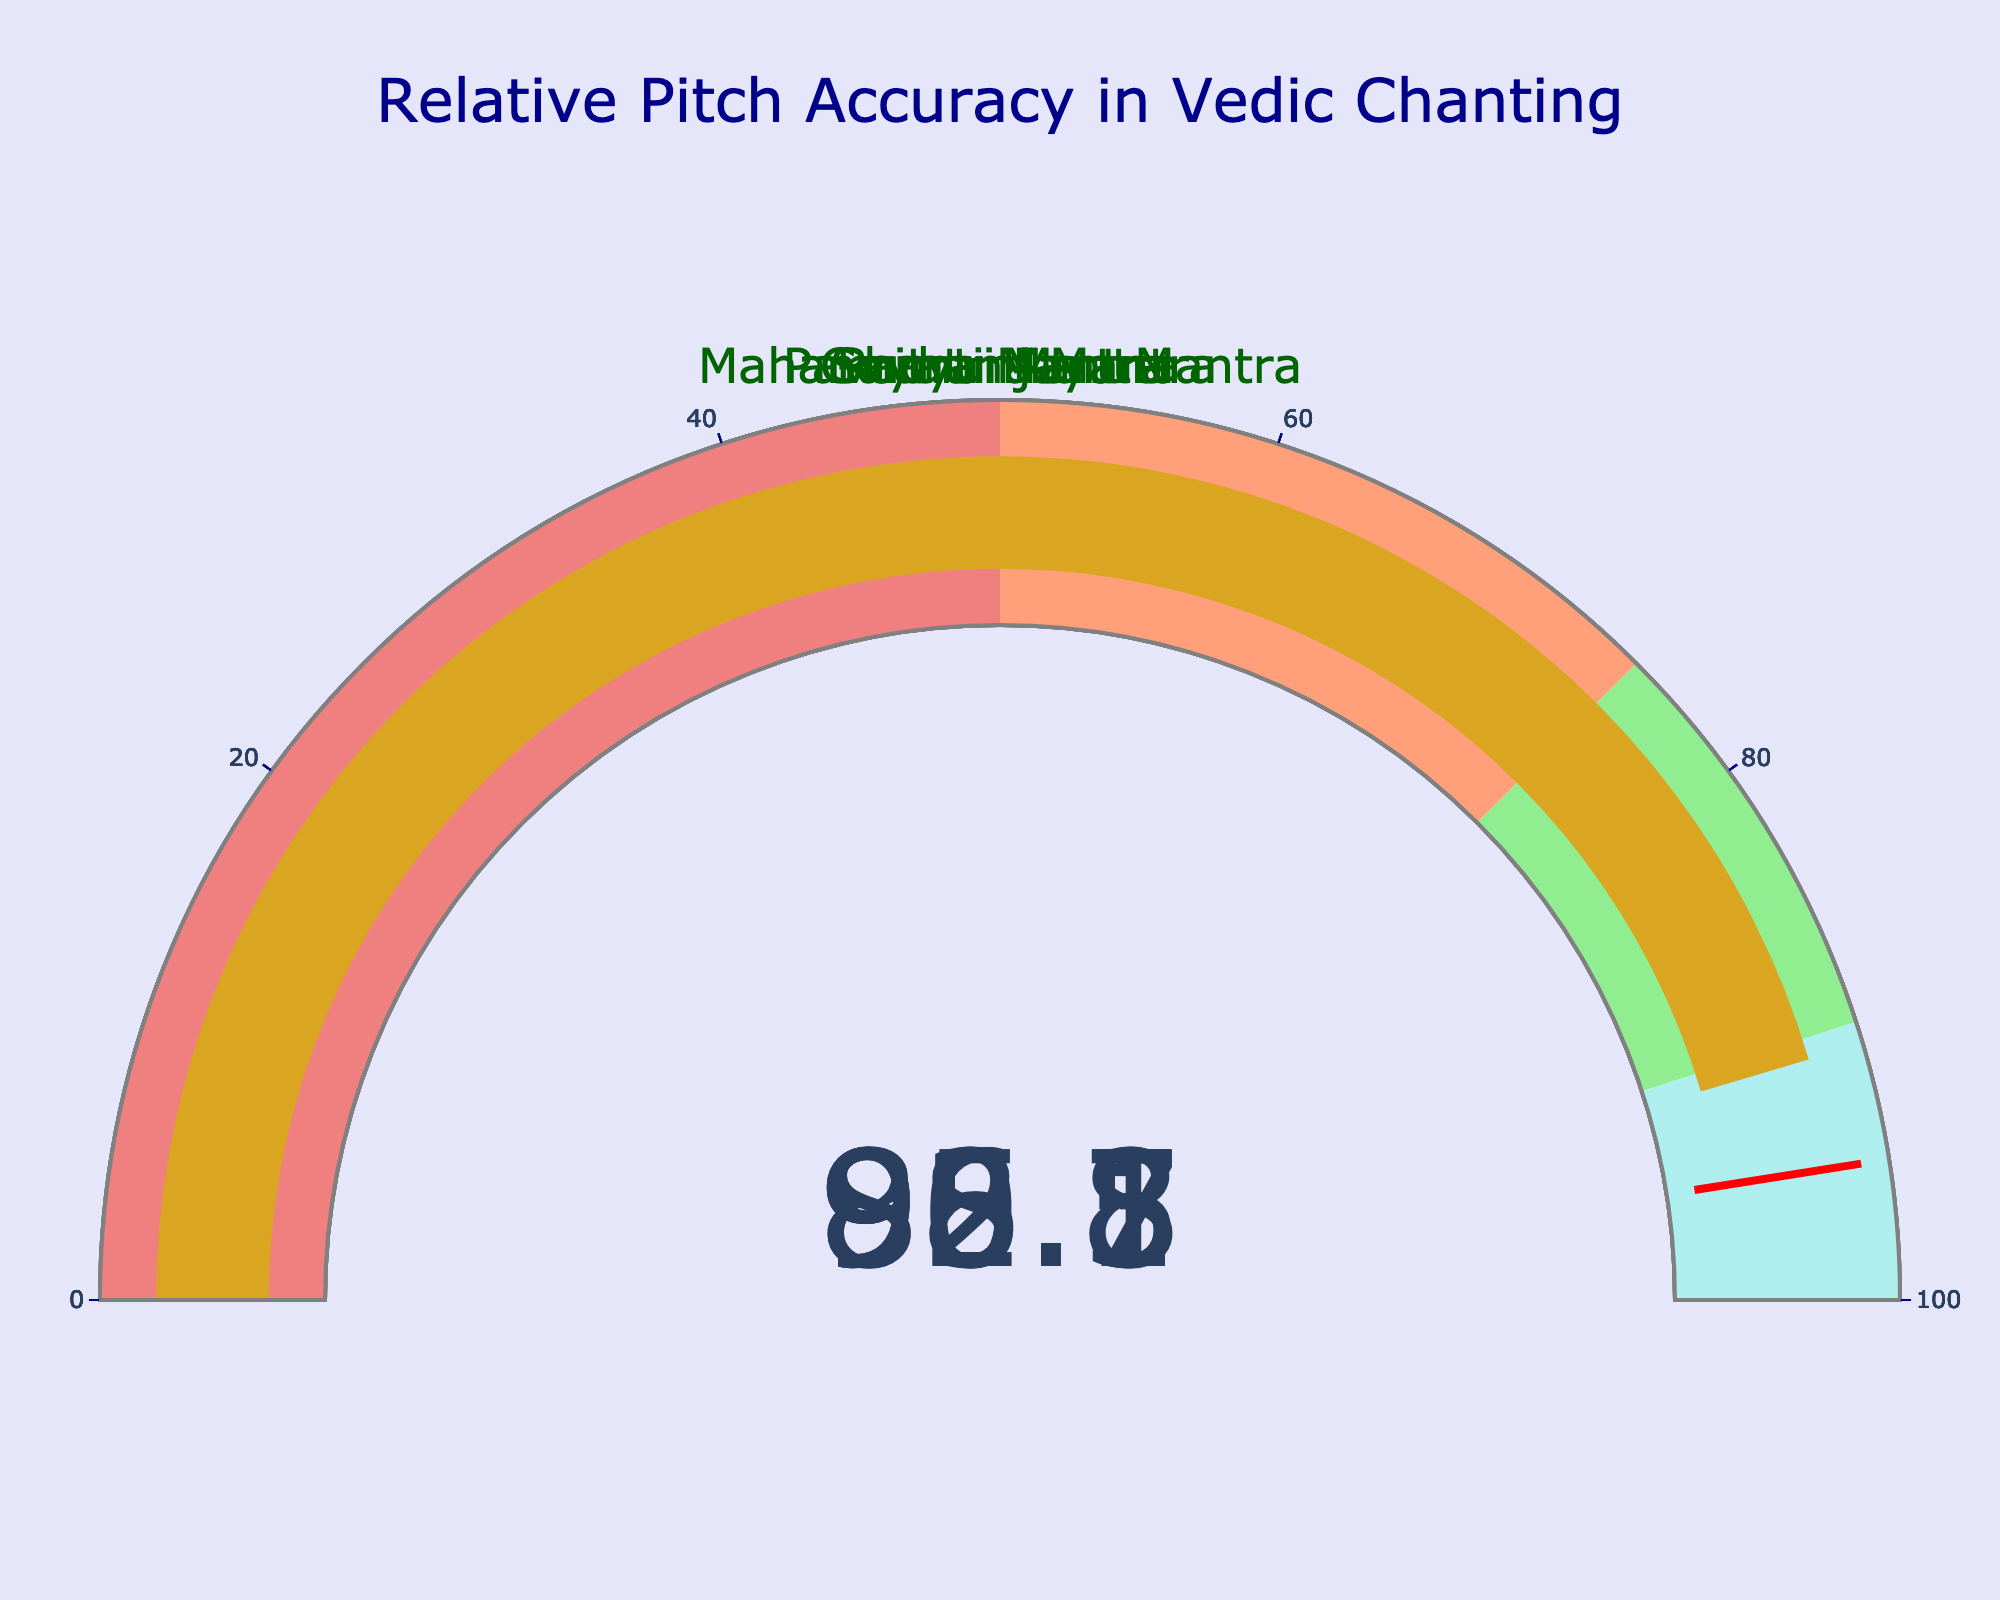What's the relative pitch accuracy of the Gayatri Mantra? The figure shows a gauge for each mantra with the pitch accuracy displayed as a number. We can directly read the Gayatri Mantra's gauge.
Answer: 92.5 How many mantras have a pitch accuracy of over 90%? By examining each gauge, we note the pitch accuracies of each mantra. Gayatri Mantra: 92.5, Mahamrityunjaya Mantra: 88.7, Shanti Mantra: 95.1, Pavamana Mantra: 86.3, Rudra Mantra: 90.8. Counting the values above 90 gives us three.
Answer: 3 What is the average relative pitch accuracy of all the mantras? We sum up all the accuracies and divide by the number of mantras: (92.5 + 88.7 + 95.1 + 86.3 + 90.8) / 5 = 453.4 / 5 = 90.68.
Answer: 90.68 Which mantra has the lowest relative pitch accuracy? By comparing the pitch accuracies directly, the lowest value is Pavamana Mantra with 86.3
Answer: Pavamana Mantra Is there any mantra with a pitch accuracy of exactly 95% or higher? Checking each gauge, the Shanti Mantra has an accuracy of 95.1, which meets the condition.
Answer: Yes What's the difference in pitch accuracy between the Shanti Mantra and the Rudra Mantra? Shanti Mantra's pitch accuracy is 95.1, and Rudra Mantra's is 90.8. The difference is 95.1 - 90.8 = 4.3.
Answer: 4.3 Which mantra has a pitch accuracy closest to 90%? We need to check the values that are closest to 90%. Rudra Mantra is 90.8, just 0.8 away. Pavamana Mantra is 86.3, 3.7 away. Gayatri Mantra is 92.5, 2.5 away. Mahamrityunjaya Mantra is 88.7, 1.3 away. Rudra Mantra is the closest.
Answer: Rudra Mantra What's the highest relative pitch accuracy among the mantras? By looking at each gauge, the highest value observed is Shanti Mantra with a pitch accuracy of 95.1.
Answer: 95.1 